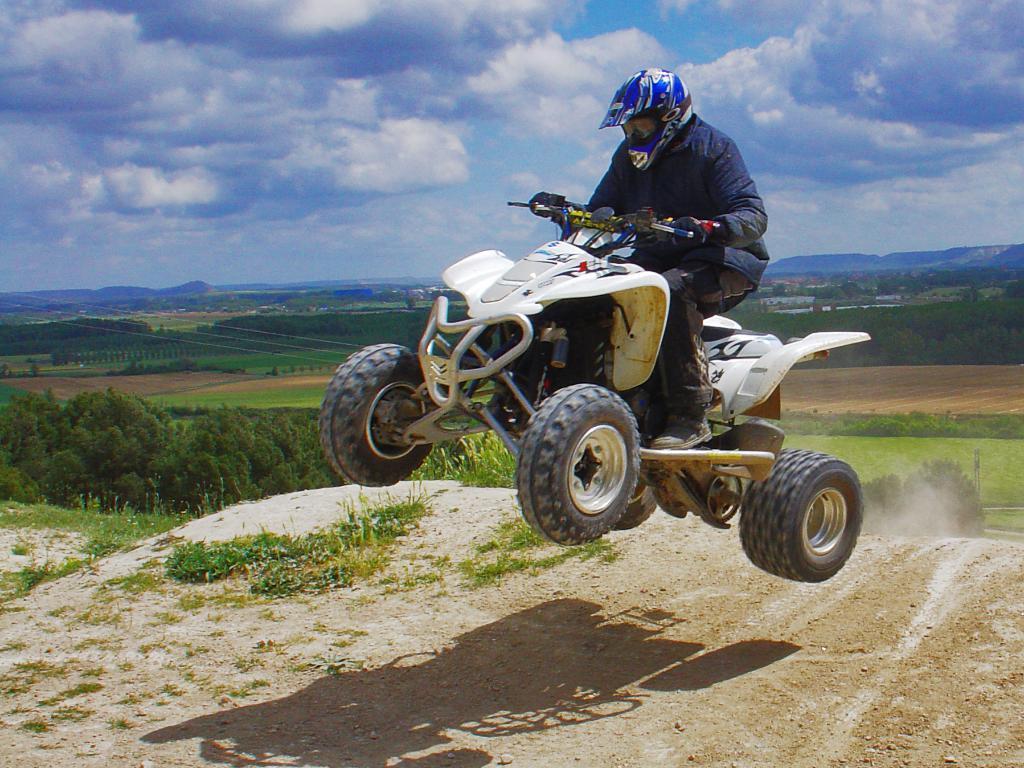Can you describe this image briefly? In this image we can see the person riding motorcycle. And there are trees, grass, ground, mountain and the sky. 